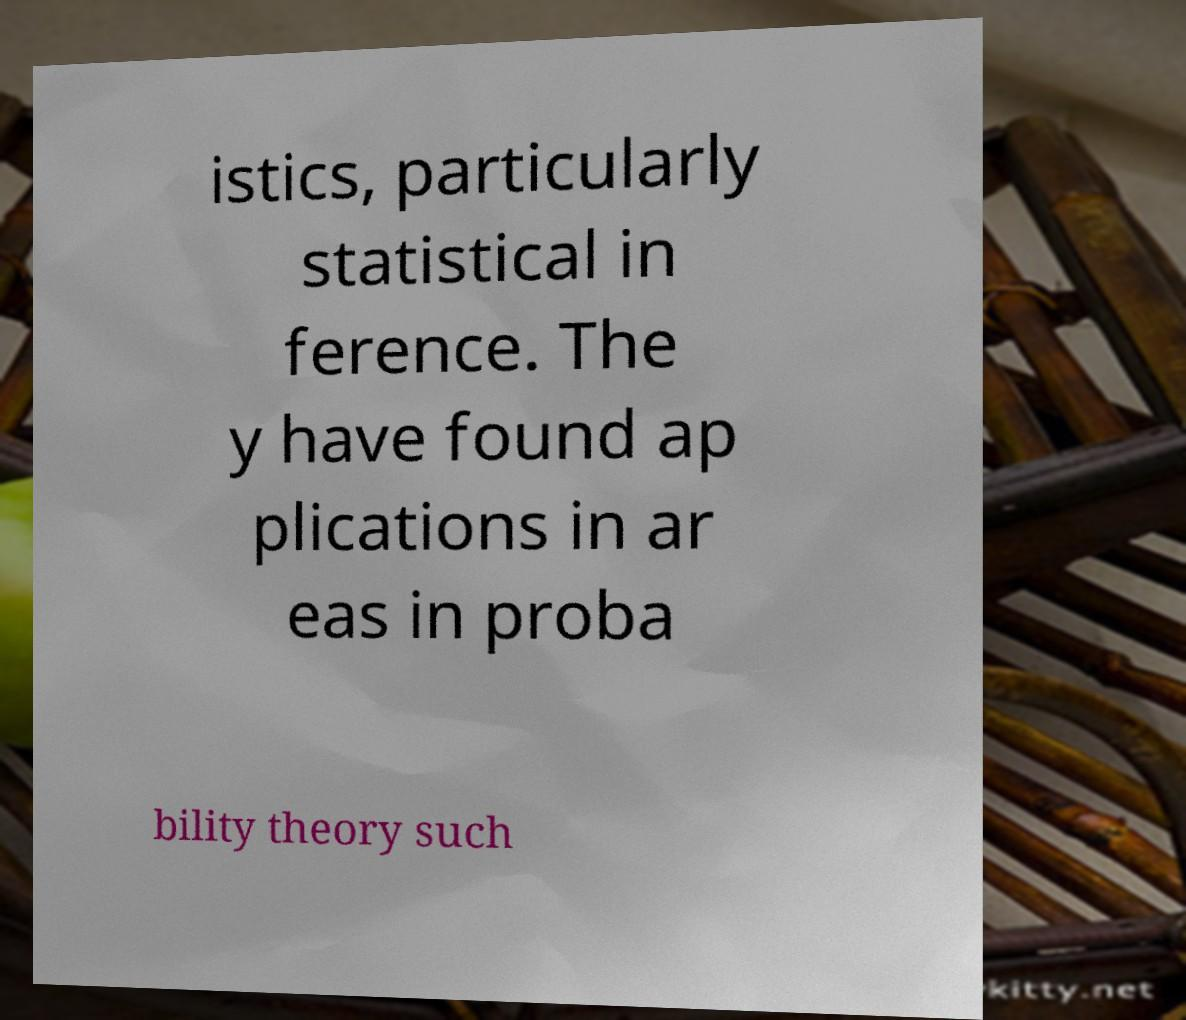Please identify and transcribe the text found in this image. istics, particularly statistical in ference. The y have found ap plications in ar eas in proba bility theory such 